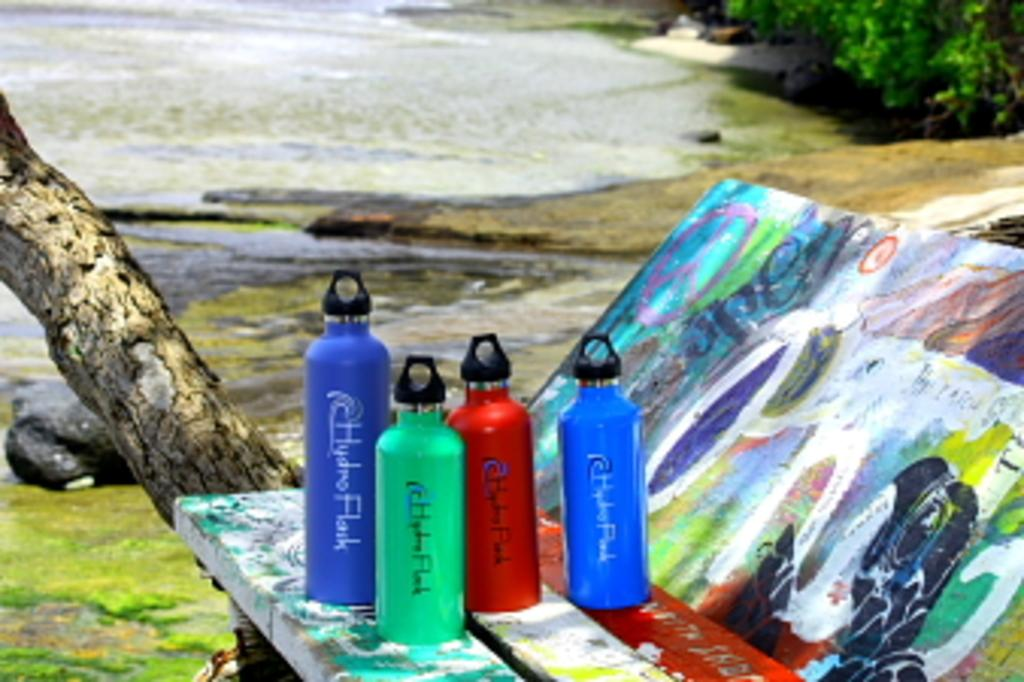Provide a one-sentence caption for the provided image. The HydroFlak bottles are available in four different colors and two different sizes. 